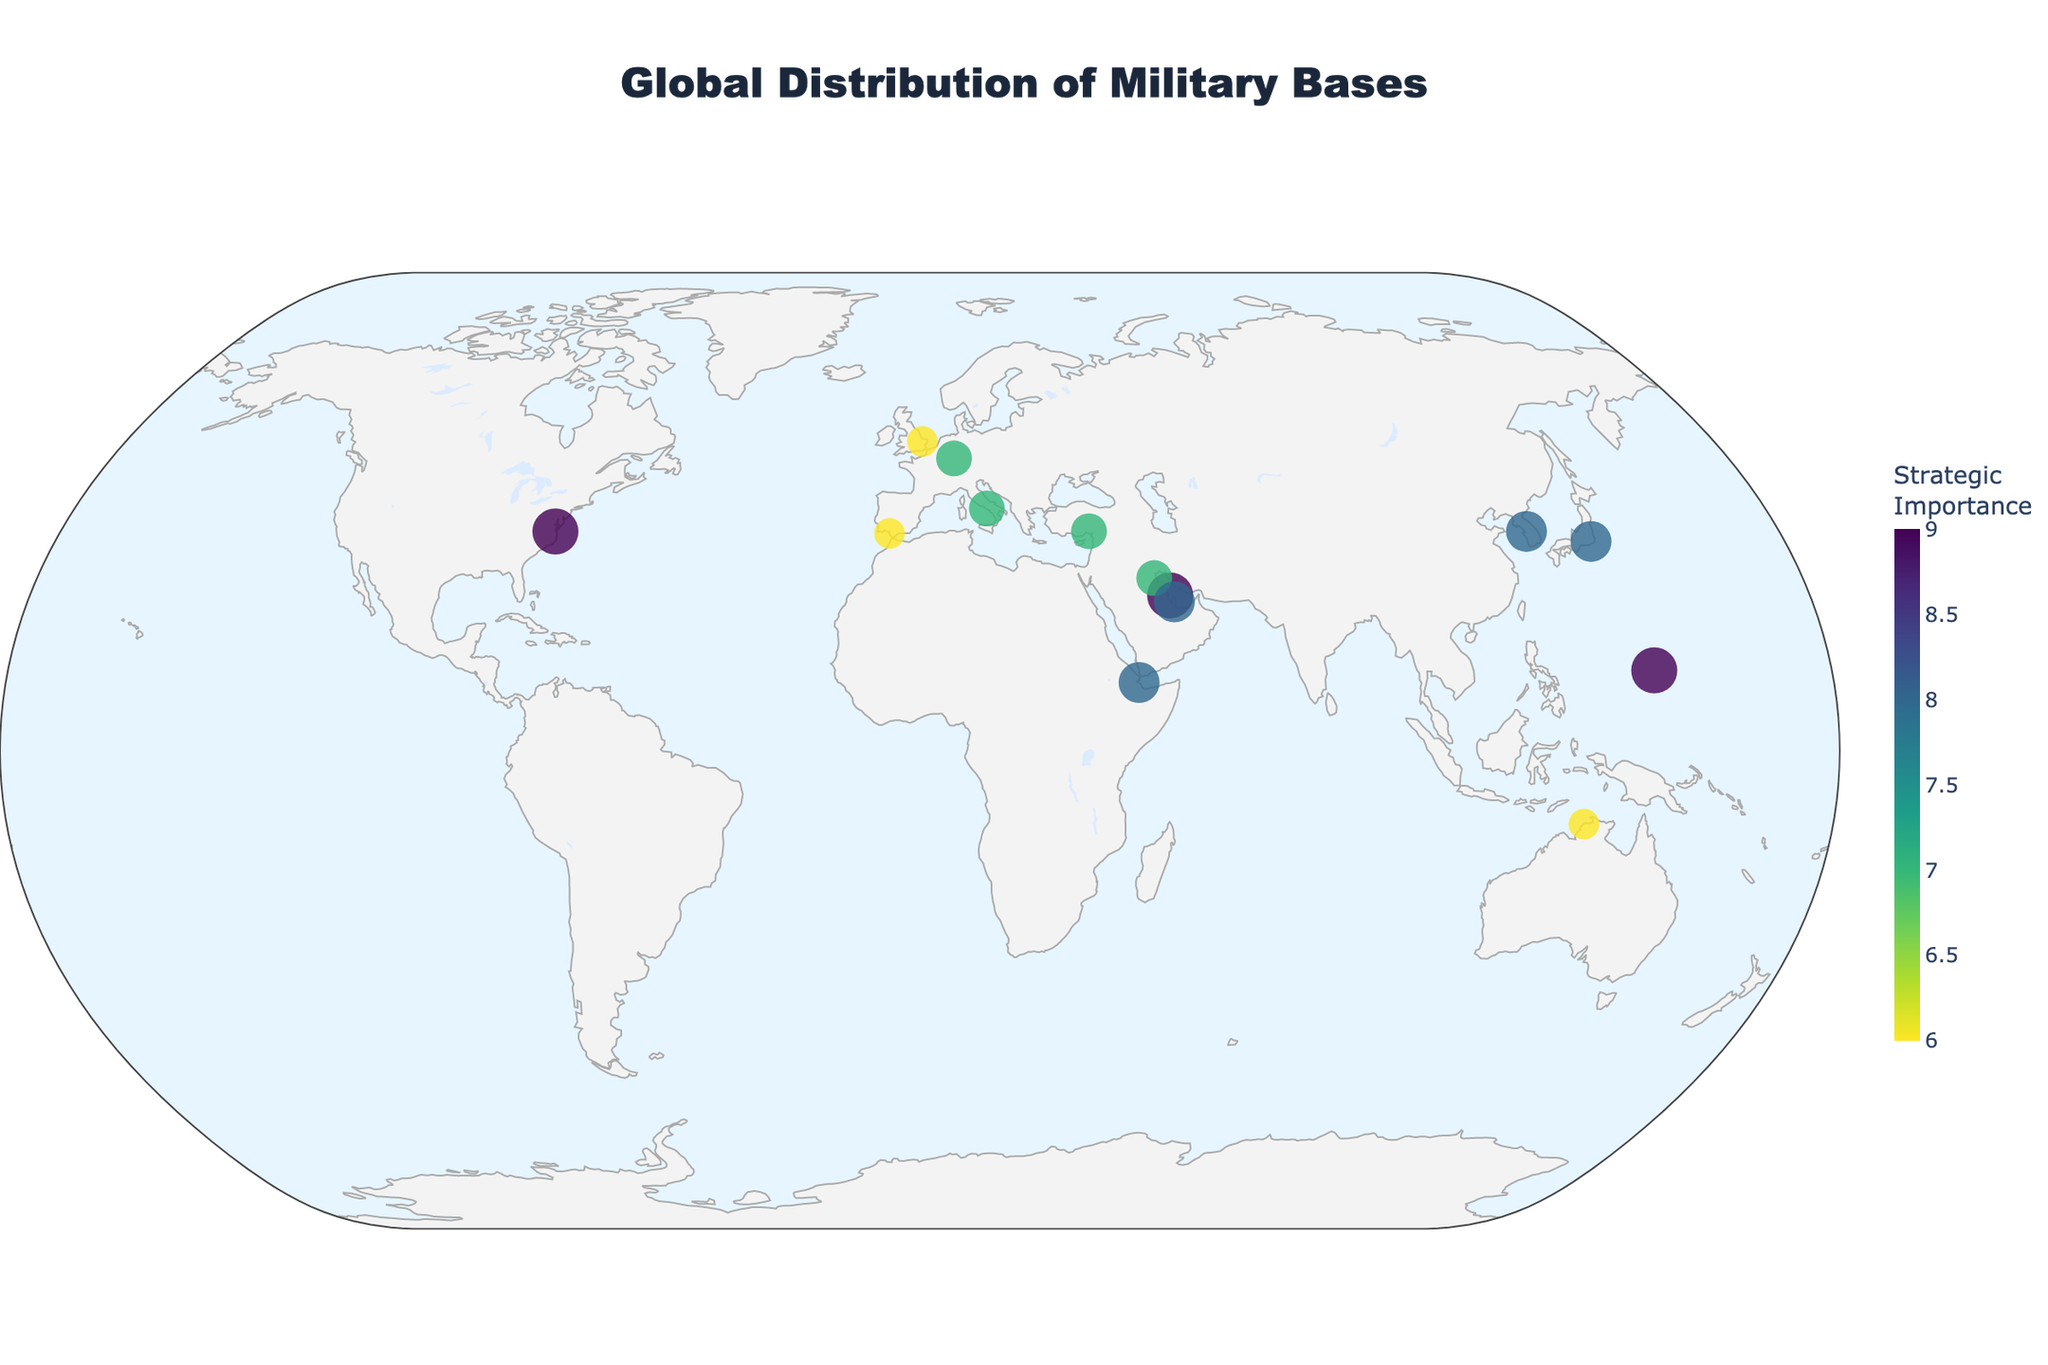What is the title of the figure? The title is displayed prominently at the top of the figure inside a box. By directly reading the text, one can identify the title.
Answer: Global Distribution of Military Bases Which military base has the highest strategic importance? By examining the size and color intensity of the markers on the plot, we see that the bases with the most prominent visual attributes are those with the highest strategic importance of 9. There are three such bases: Naval Station Norfolk (USA), Naval Support Activity Bahrain (Bahrain), and Andersen Air Force Base (Guam).
Answer: Naval Station Norfolk, Naval Support Activity Bahrain, Andersen Air Force Base (all equally highest) How many military bases have a strategic importance value of 8 or higher? The color and size of the markers indicate the strategic importance of each base. Military bases with a score of 8 or higher are marked with more vibrant colors and larger sizes. Counting these markers reveals the total number.
Answer: 6 Which country hosts the largest number of U.S. military bases shown in the figure? By scanning the distribution of the markers and referring to the associated text labels, we identify the markers labeled with "United States" and count them.
Answer: United States (multiple locations) Compare the strategic importance of Yokosuka Naval Base in Japan and RAF Lakenheath in the United Kingdom. Which one is more strategically important? By comparing the color and size of the markers for Yokosuka Naval Base and RAF Lakenheath, we see that Yokosuka Naval Base has a strategic importance of 8, whereas RAF Lakenheath has an importance of 6.
Answer: Yokosuka Naval Base (Japan) Which regions (continent-wise) seem to have the highest concentration of high strategic importance military bases? By examining the distribution of markers with strategic importance scores of 7 or higher, we see concentrations in regions such as Asia (Japan, South Korea, Bahrain), the Middle East (Bahrain, Qatar, Kuwait), and the Pacific (Guam). These continents hold multiple bases of high strategic importance.
Answer: Asia, Middle East, Pacific Identify the military base with a strategic importance of 7 located at the 37°N latitude approximate line. Checking the plot for a marker around 37°N latitude, we find one such marker in Turkey for Incirlik Air Base.
Answer: Incirlik Air Base (Turkey) 